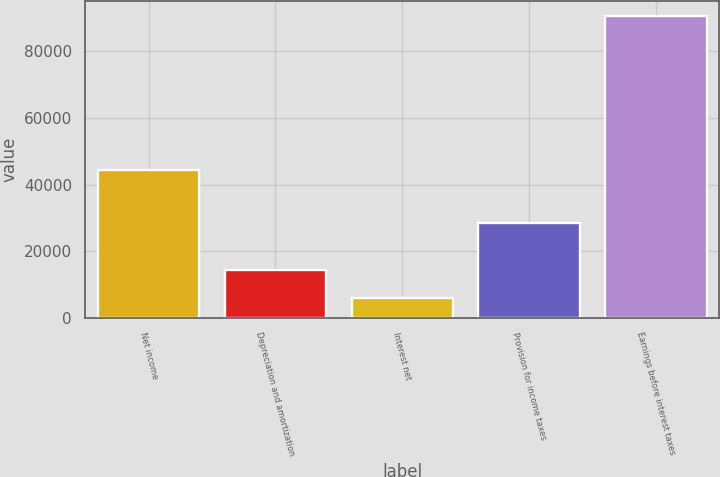<chart> <loc_0><loc_0><loc_500><loc_500><bar_chart><fcel>Net income<fcel>Depreciation and amortization<fcel>Interest net<fcel>Provision for income taxes<fcel>Earnings before interest taxes<nl><fcel>44395<fcel>14314.7<fcel>5824<fcel>28426<fcel>90731<nl></chart> 